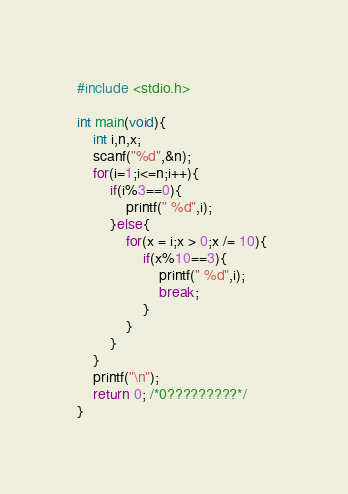Convert code to text. <code><loc_0><loc_0><loc_500><loc_500><_C_>#include <stdio.h>

int main(void){
    int i,n,x;
    scanf("%d",&n);
    for(i=1;i<=n;i++){
        if(i%3==0){
            printf(" %d",i);
        }else{
            for(x = i;x > 0;x /= 10){ 
                if(x%10==3){
                    printf(" %d",i);
                    break;
                }
            }
        }
    }
    printf("\n");
    return 0; /*0?????????*/
}</code> 